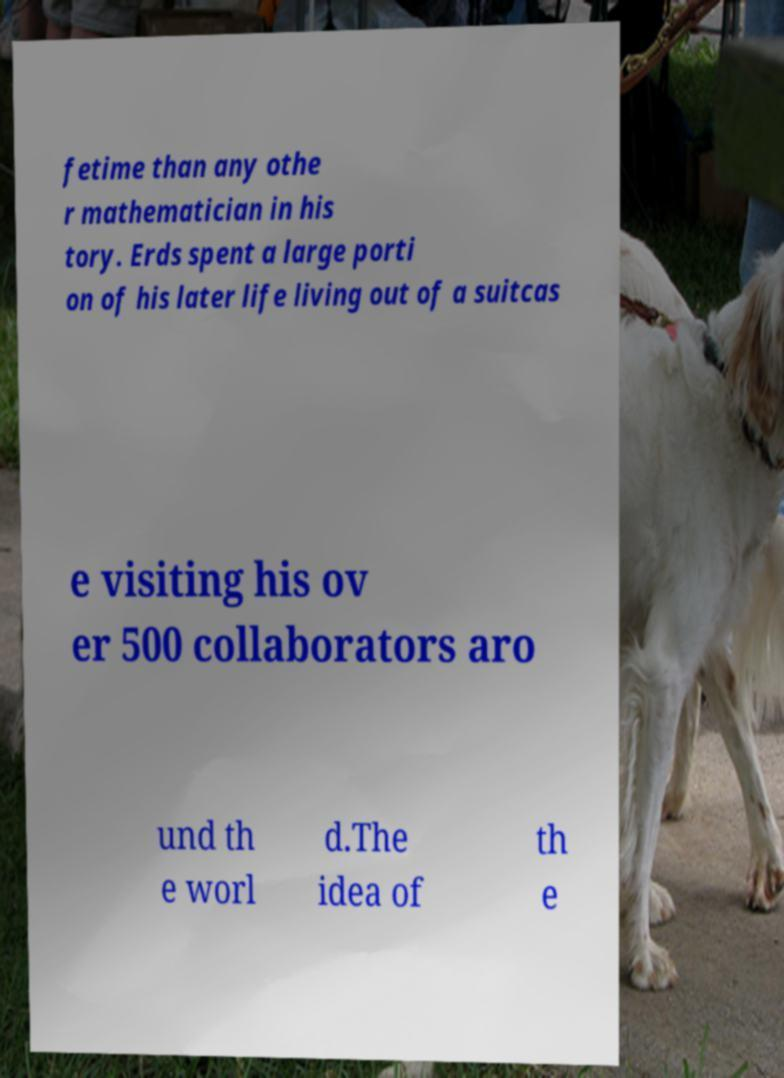Please read and relay the text visible in this image. What does it say? fetime than any othe r mathematician in his tory. Erds spent a large porti on of his later life living out of a suitcas e visiting his ov er 500 collaborators aro und th e worl d.The idea of th e 